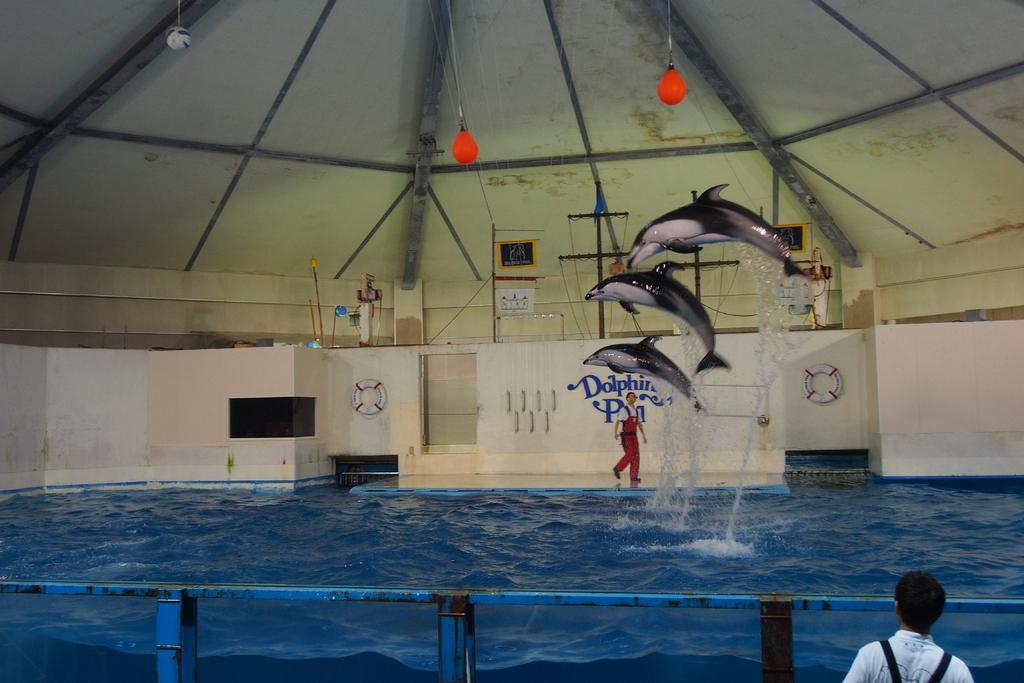Can you describe this image briefly? In this image we can see the dolphin show, swimming tubes, shed, swimming pool, iron poles and persons. 